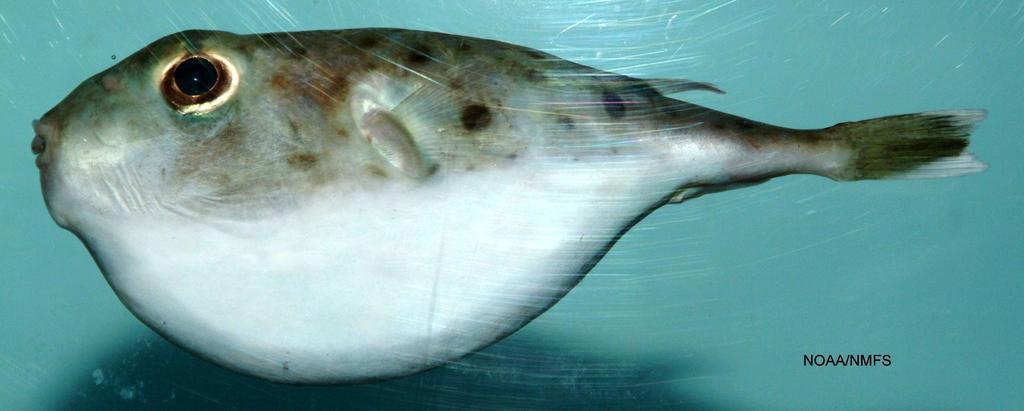Describe this image in one or two sentences. In this image there is a fish in the water. 